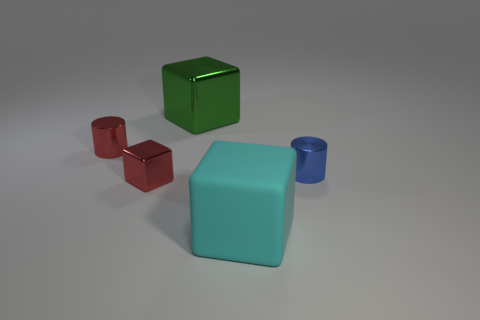Add 4 big matte cubes. How many objects exist? 9 Subtract all cylinders. How many objects are left? 3 Add 5 large yellow objects. How many large yellow objects exist? 5 Subtract 0 green cylinders. How many objects are left? 5 Subtract all large cyan rubber cubes. Subtract all tiny red cubes. How many objects are left? 3 Add 5 tiny red shiny cubes. How many tiny red shiny cubes are left? 6 